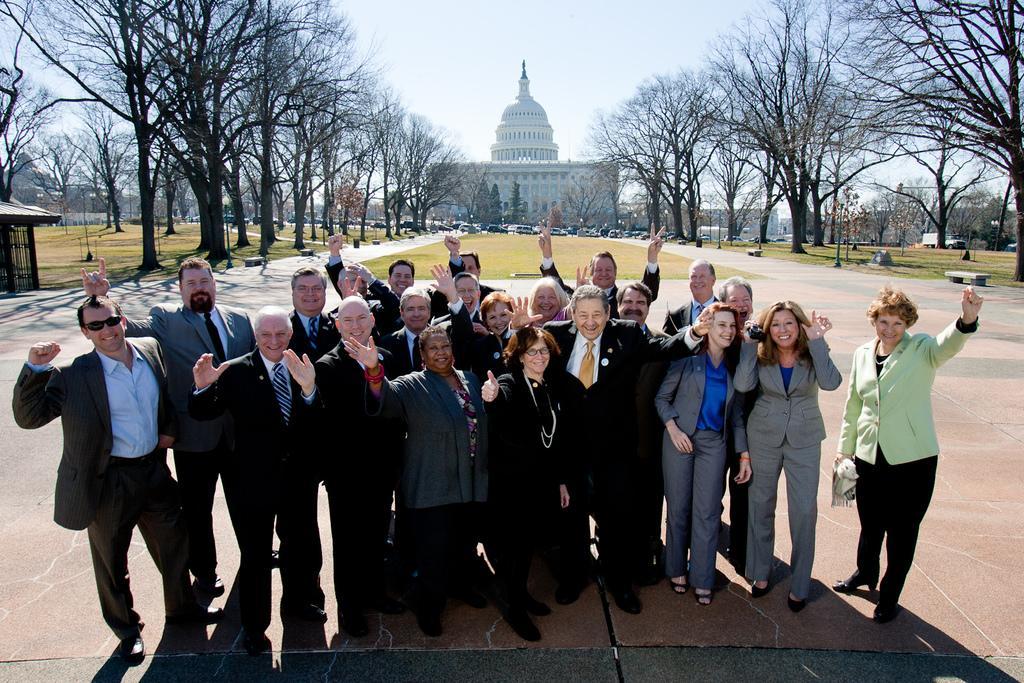Please provide a concise description of this image. In the picture I can see a group of people standing on the floor and I can see the smile on their faces. There are trees on the left side and the right side. In the background, I can see the building and I can see the dome construction at the top of the building. In the background, I can see the cars on the road. I can see the marble benches on the side of the road. There are clouds in the sky. 